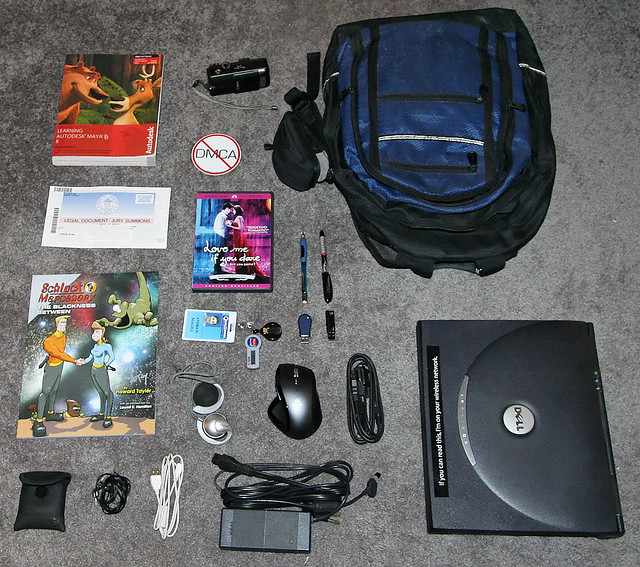Identify and read out the text in this image. DCMA me Love Love DELL 